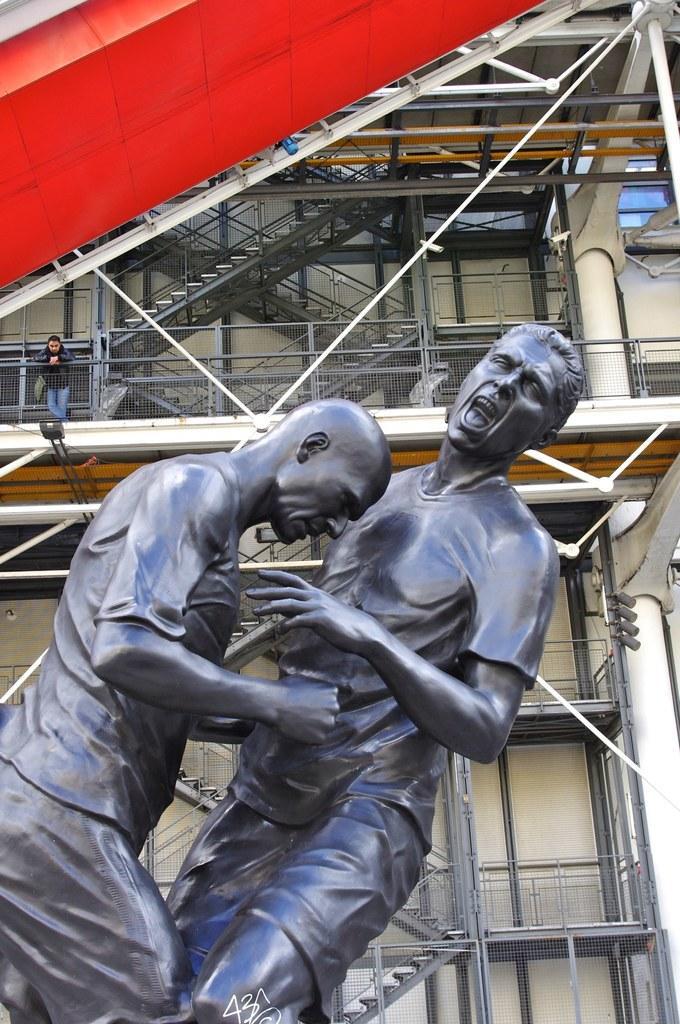In one or two sentences, can you explain what this image depicts? This image consists of statues of two men. In the background, there is a building along with stairs. And a man is standing near the railing. 